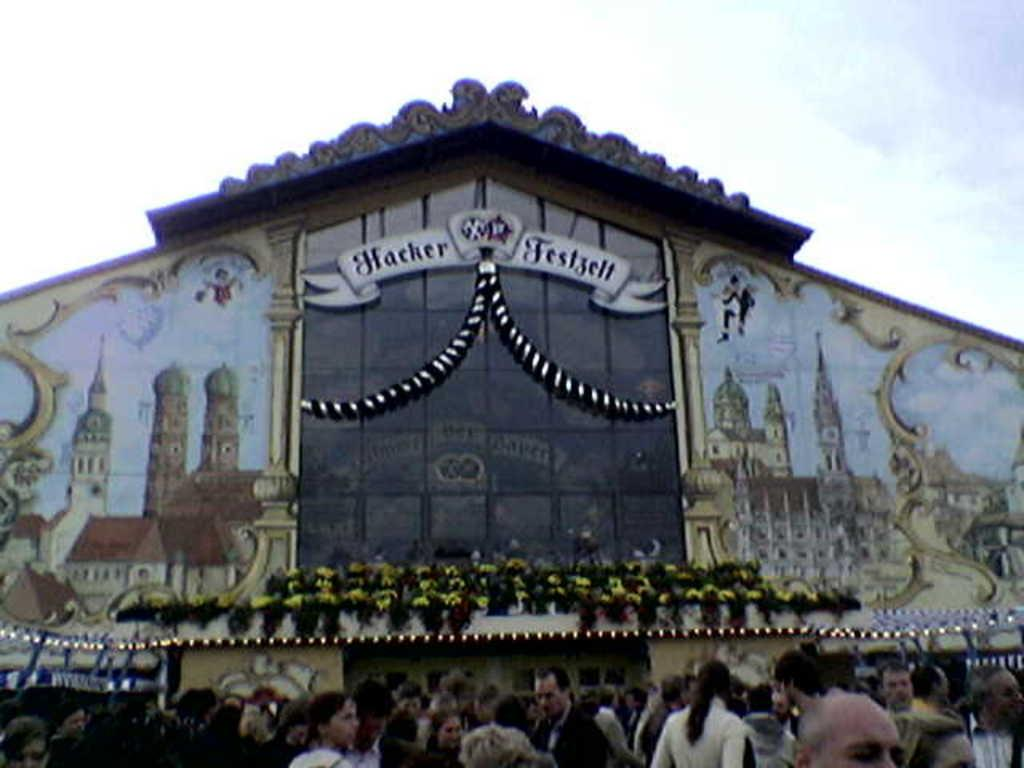<image>
Relay a brief, clear account of the picture shown. A large ornate building with the word Hacker on the left 